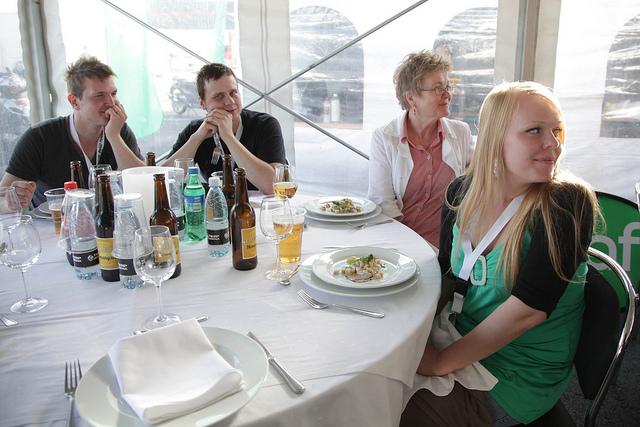Is everyone looking in the same direction?
Write a very short answer. Yes. How many people are sitting at the table in this picture?
Quick response, please. 4. What is covering the table?
Quick response, please. Tablecloth. 